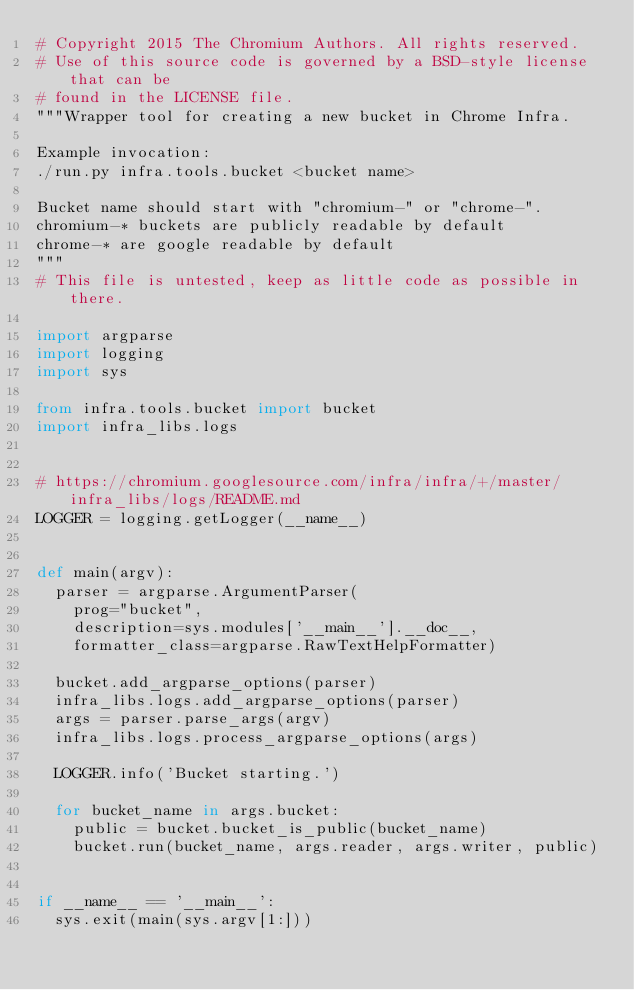<code> <loc_0><loc_0><loc_500><loc_500><_Python_># Copyright 2015 The Chromium Authors. All rights reserved.
# Use of this source code is governed by a BSD-style license that can be
# found in the LICENSE file.
"""Wrapper tool for creating a new bucket in Chrome Infra.

Example invocation:
./run.py infra.tools.bucket <bucket name>

Bucket name should start with "chromium-" or "chrome-".
chromium-* buckets are publicly readable by default
chrome-* are google readable by default
"""
# This file is untested, keep as little code as possible in there.

import argparse
import logging
import sys

from infra.tools.bucket import bucket
import infra_libs.logs


# https://chromium.googlesource.com/infra/infra/+/master/infra_libs/logs/README.md
LOGGER = logging.getLogger(__name__)


def main(argv):
  parser = argparse.ArgumentParser(
    prog="bucket",
    description=sys.modules['__main__'].__doc__,
    formatter_class=argparse.RawTextHelpFormatter)

  bucket.add_argparse_options(parser)
  infra_libs.logs.add_argparse_options(parser)
  args = parser.parse_args(argv)
  infra_libs.logs.process_argparse_options(args)

  LOGGER.info('Bucket starting.')

  for bucket_name in args.bucket:
    public = bucket.bucket_is_public(bucket_name)
    bucket.run(bucket_name, args.reader, args.writer, public)


if __name__ == '__main__':
  sys.exit(main(sys.argv[1:]))
</code> 